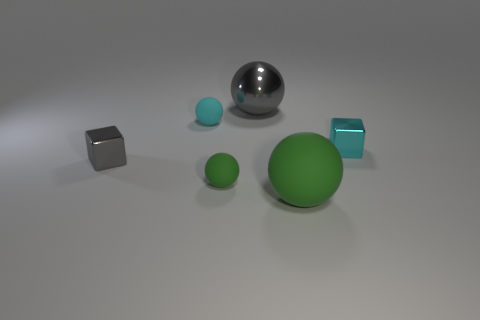Is the gray cube made of the same material as the small sphere that is behind the cyan metallic object?
Provide a short and direct response. No. Is the shape of the large green rubber thing the same as the cyan object to the left of the small green rubber sphere?
Offer a terse response. Yes. What number of objects are either gray rubber cylinders or green matte things on the left side of the large green ball?
Provide a short and direct response. 1. There is a cube to the left of the shiny sphere; is it the same size as the tiny cyan shiny block?
Make the answer very short. Yes. How many other objects are the same shape as the small green rubber object?
Offer a terse response. 3. What number of brown objects are either tiny metal cubes or spheres?
Your response must be concise. 0. Do the tiny metallic object to the left of the large shiny sphere and the big metallic ball have the same color?
Provide a short and direct response. Yes. There is a gray thing that is made of the same material as the large gray sphere; what shape is it?
Offer a very short reply. Cube. There is a metal object that is in front of the shiny sphere and on the left side of the large green rubber ball; what color is it?
Provide a succinct answer. Gray. What size is the rubber ball behind the tiny cyan thing that is on the right side of the cyan rubber ball?
Provide a short and direct response. Small. 